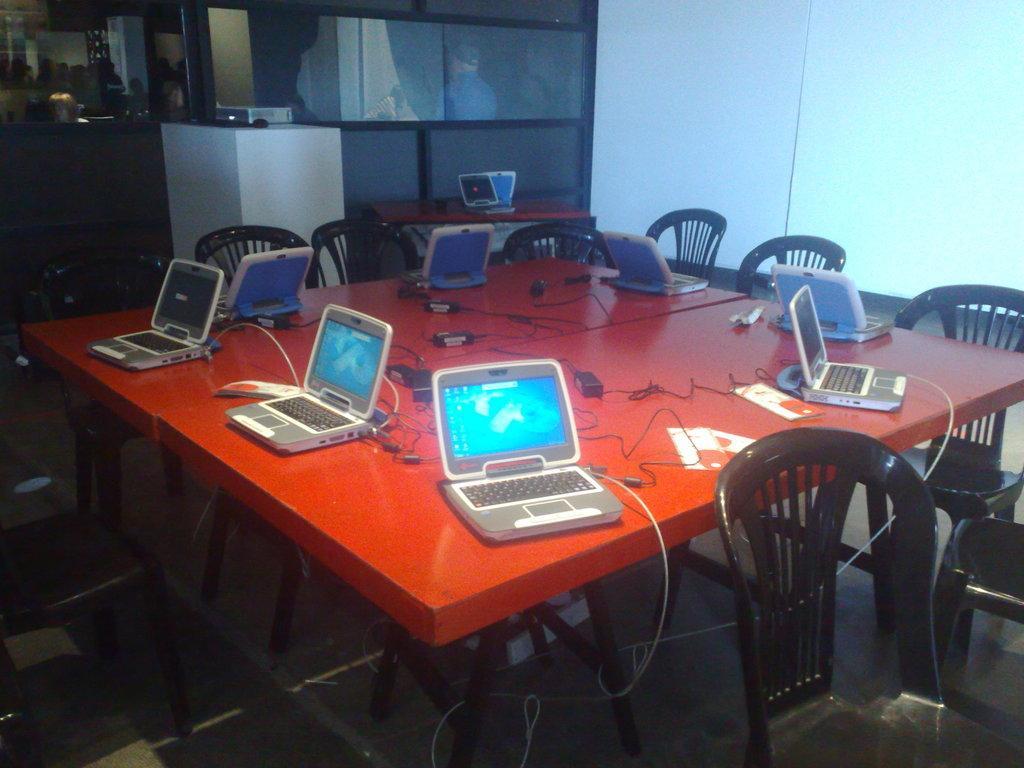Could you give a brief overview of what you see in this image? There are laptops on the table and chairs around it. 